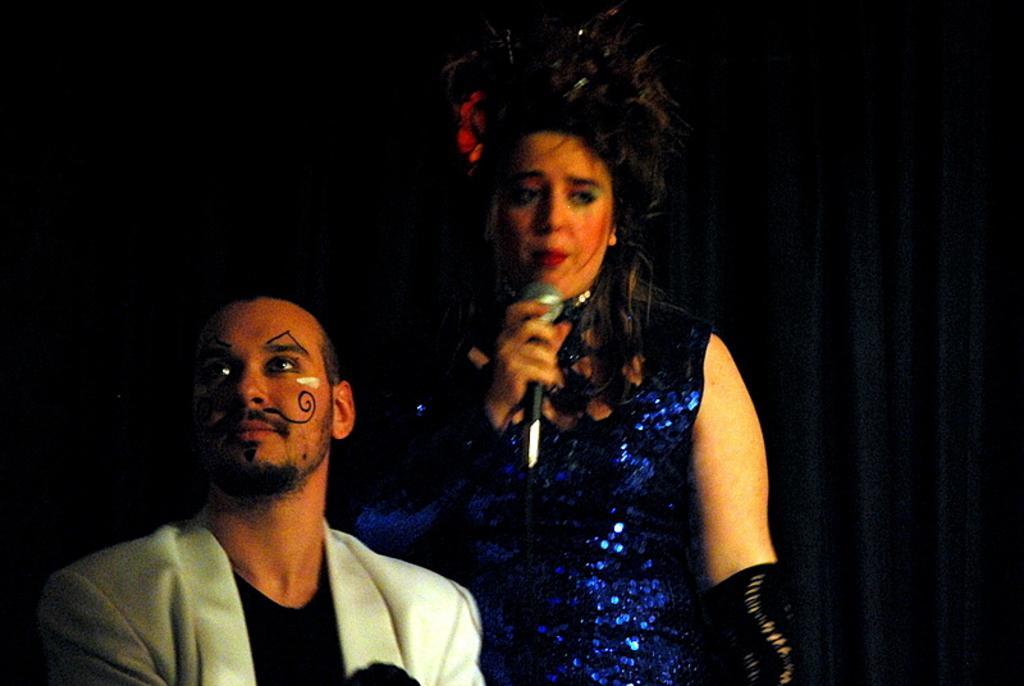How would you summarize this image in a sentence or two? In this in front there are two persons in which right side person is holding the mike. Behind her there are curtains. 